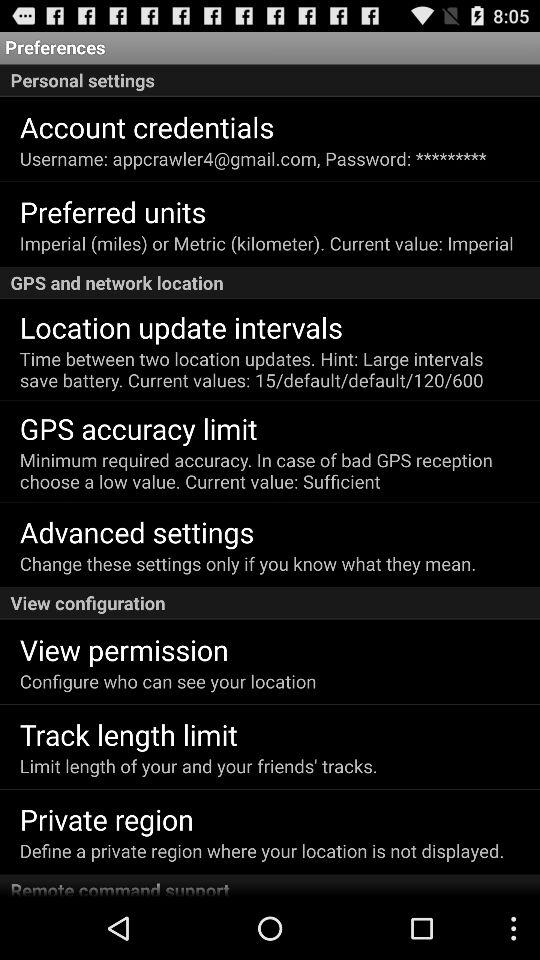Which option is selected in the current value for the preferred unit setting? The selected option is "Imperial". 